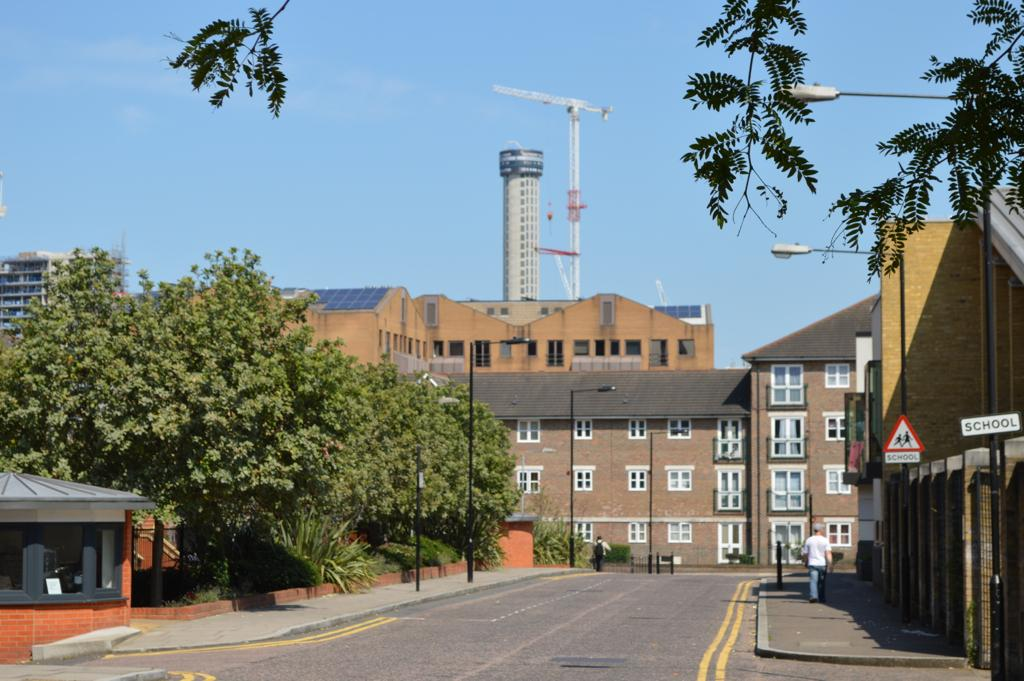What is the main feature in the center of the image? There is a sky in the center of the image. What type of structures can be seen in the image? There are buildings, a tower, and a pole-type structure in the image. What are some other elements present in the image? Windows, trees, poles, sign boards, a road, and two persons are visible in the image. Can you tell me where the kettle is located in the image? There is no kettle present in the image. How does the quill move around in the image? There is no quill present in the image, so it cannot move around. 